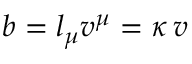Convert formula to latex. <formula><loc_0><loc_0><loc_500><loc_500>b = l _ { \mu } v ^ { \mu } = \kappa \, v</formula> 